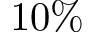Convert formula to latex. <formula><loc_0><loc_0><loc_500><loc_500>1 0 \%</formula> 